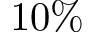Convert formula to latex. <formula><loc_0><loc_0><loc_500><loc_500>1 0 \%</formula> 